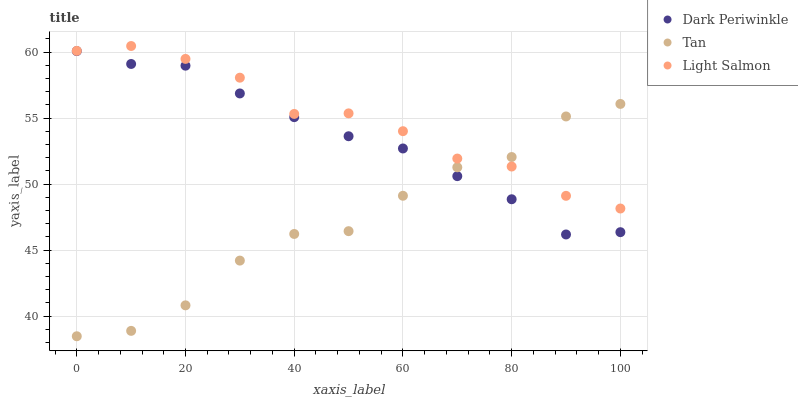Does Tan have the minimum area under the curve?
Answer yes or no. Yes. Does Light Salmon have the maximum area under the curve?
Answer yes or no. Yes. Does Dark Periwinkle have the minimum area under the curve?
Answer yes or no. No. Does Dark Periwinkle have the maximum area under the curve?
Answer yes or no. No. Is Dark Periwinkle the smoothest?
Answer yes or no. Yes. Is Tan the roughest?
Answer yes or no. Yes. Is Light Salmon the smoothest?
Answer yes or no. No. Is Light Salmon the roughest?
Answer yes or no. No. Does Tan have the lowest value?
Answer yes or no. Yes. Does Dark Periwinkle have the lowest value?
Answer yes or no. No. Does Light Salmon have the highest value?
Answer yes or no. Yes. Does Dark Periwinkle have the highest value?
Answer yes or no. No. Is Dark Periwinkle less than Light Salmon?
Answer yes or no. Yes. Is Light Salmon greater than Dark Periwinkle?
Answer yes or no. Yes. Does Dark Periwinkle intersect Tan?
Answer yes or no. Yes. Is Dark Periwinkle less than Tan?
Answer yes or no. No. Is Dark Periwinkle greater than Tan?
Answer yes or no. No. Does Dark Periwinkle intersect Light Salmon?
Answer yes or no. No. 